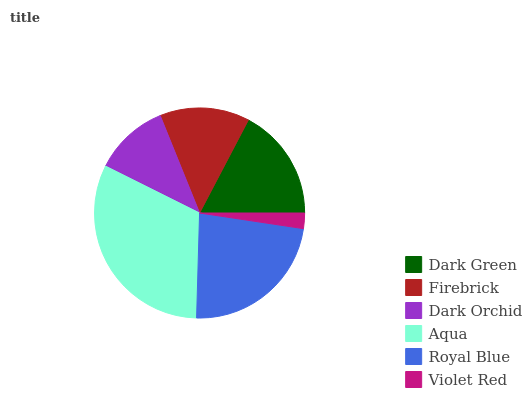Is Violet Red the minimum?
Answer yes or no. Yes. Is Aqua the maximum?
Answer yes or no. Yes. Is Firebrick the minimum?
Answer yes or no. No. Is Firebrick the maximum?
Answer yes or no. No. Is Dark Green greater than Firebrick?
Answer yes or no. Yes. Is Firebrick less than Dark Green?
Answer yes or no. Yes. Is Firebrick greater than Dark Green?
Answer yes or no. No. Is Dark Green less than Firebrick?
Answer yes or no. No. Is Dark Green the high median?
Answer yes or no. Yes. Is Firebrick the low median?
Answer yes or no. Yes. Is Dark Orchid the high median?
Answer yes or no. No. Is Aqua the low median?
Answer yes or no. No. 